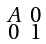Convert formula to latex. <formula><loc_0><loc_0><loc_500><loc_500>\begin{smallmatrix} A & 0 \\ 0 & 1 \end{smallmatrix}</formula> 